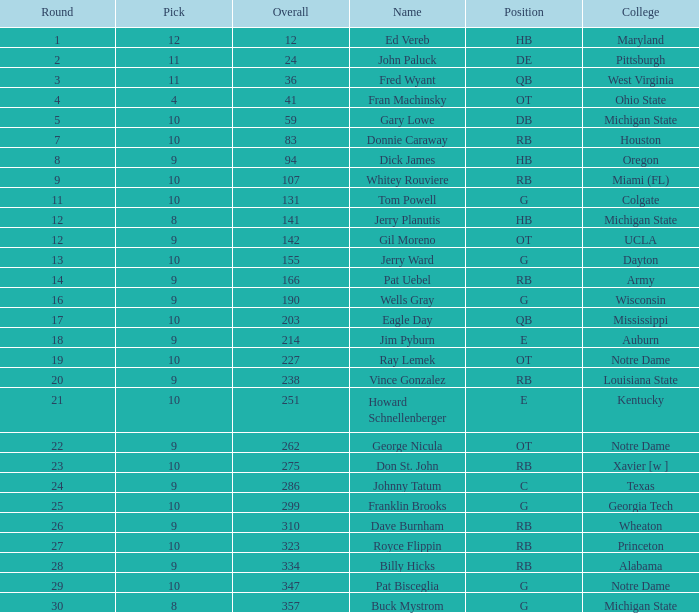How many rounds are there with a 9 pick and the name jim pyburn? 18.0. 